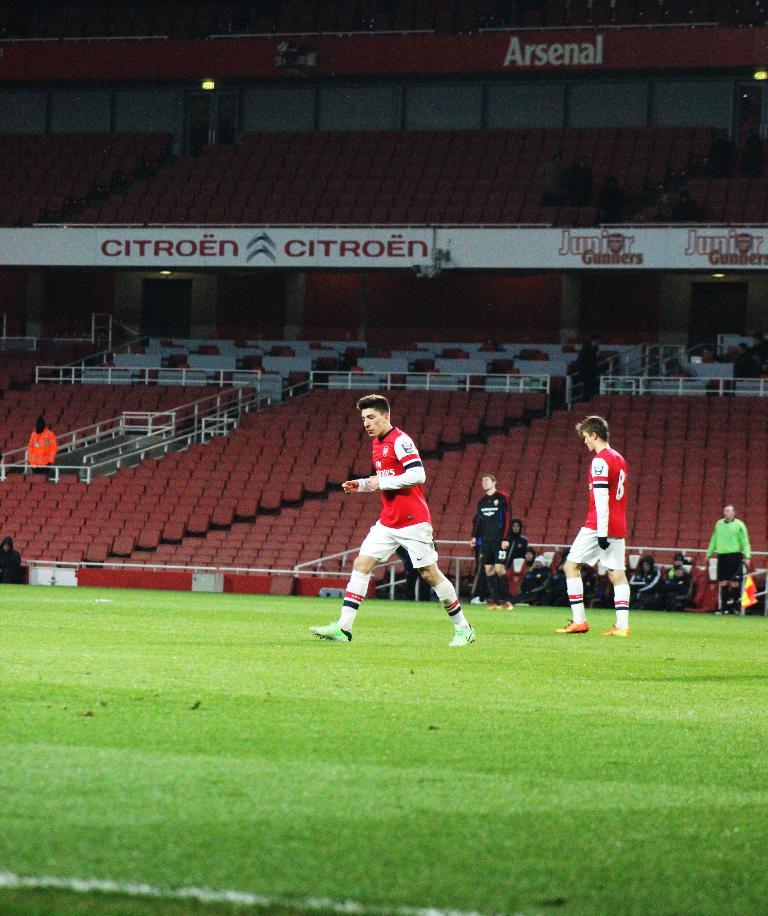Which team name is shown above the seats?
Your answer should be very brief. Arsenal. What company sponsors the white banner?
Your answer should be compact. Citroen. 